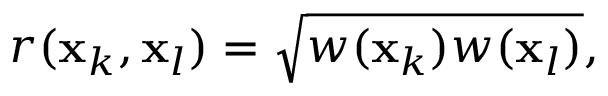Convert formula to latex. <formula><loc_0><loc_0><loc_500><loc_500>r ( x _ { k } , x _ { l } ) = \sqrt { w ( x _ { k } ) w ( x _ { l } ) } ,</formula> 